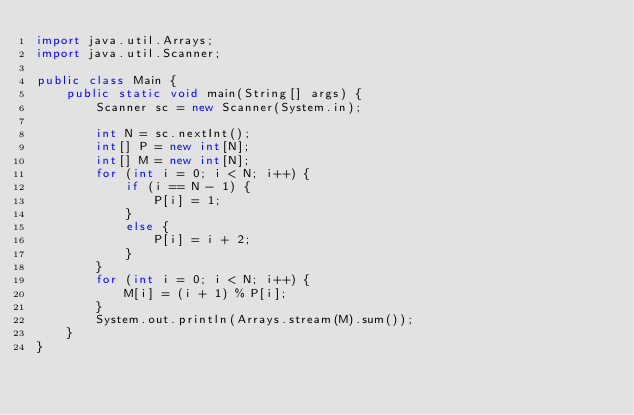<code> <loc_0><loc_0><loc_500><loc_500><_Java_>import java.util.Arrays;
import java.util.Scanner;

public class Main {
	public static void main(String[] args) {
		Scanner sc = new Scanner(System.in);

		int N = sc.nextInt();
		int[] P = new int[N];
		int[] M = new int[N];
		for (int i = 0; i < N; i++) {
			if (i == N - 1) {
				P[i] = 1;
			}
			else {
				P[i] = i + 2;
			}
		}
		for (int i = 0; i < N; i++) {
			M[i] = (i + 1) % P[i];
		}
		System.out.println(Arrays.stream(M).sum());
	}
}</code> 